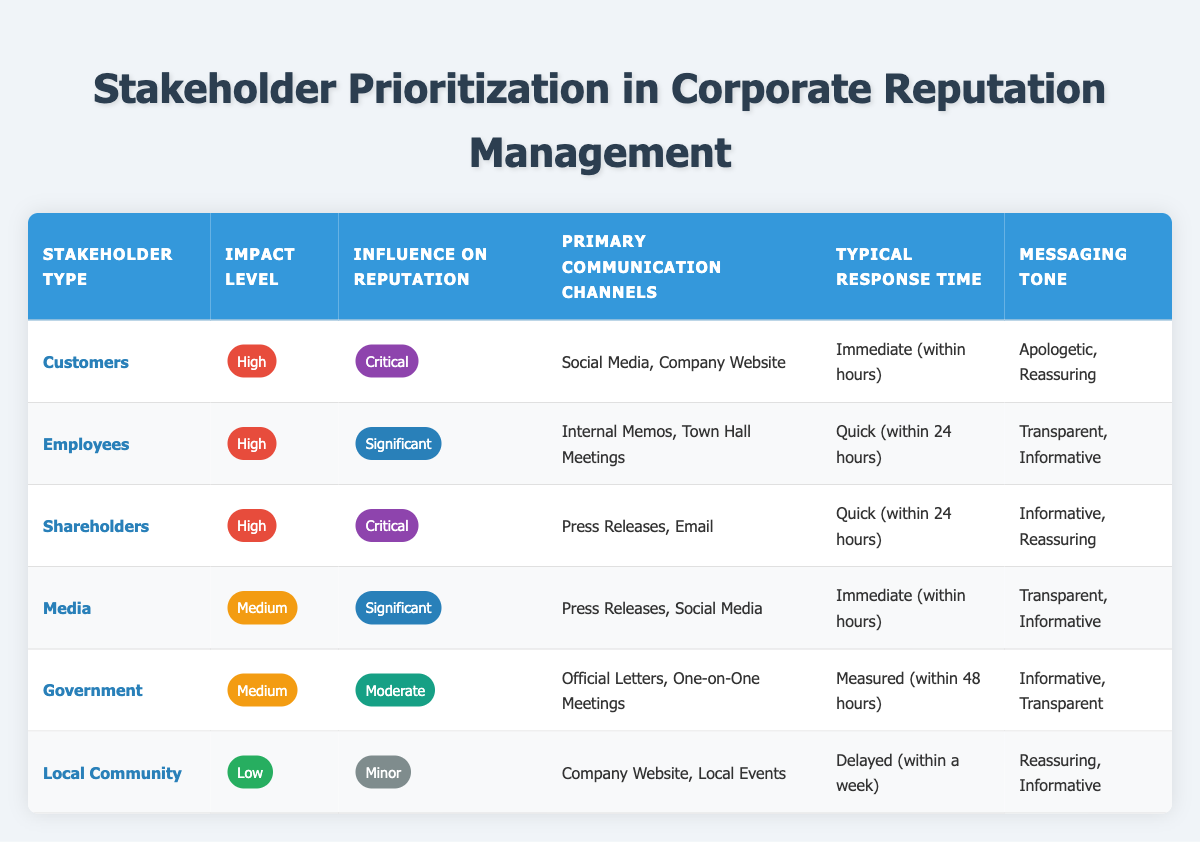What is the primary communication channel for employees? The table lists the primary communication channels for employees as "Internal Memos, Town Hall Meetings."
Answer: Internal Memos, Town Hall Meetings Which stakeholder type has a low impact level? In the table, local community is categorized under a low impact level.
Answer: Local Community How many stakeholder types have a critical influence on reputation? The table shows two stakeholder types: Customers and Shareholders which have a critical influence on reputation.
Answer: 2 What is the typical response time for shareholders? The table indicates that the typical response time for shareholders is "Quick (within 24 hours)."
Answer: Quick (within 24 hours) Which communication channel is used for immediate responses? The table details that "Social Media" and "Press Releases" are used for immediate response channels.
Answer: Social Media, Press Releases What is the average impact level of the stakeholders presented in the table? The stakeholders categorized as "High" (Customers, Employees, Shareholders), "Medium" (Media, Government), and "Low" (Local Community) show that the average impact is mostly high, depending on the frequency of high levels. To summarize with a straightforward method, the impact levels can be simplified as 3 High, 2 Medium, and 1 Low, giving more weight to high overall.
Answer: High Is the messaging tone for local community primarily reassuring? Based on the table, the messaging tone for local community includes "Reassuring" and "Informative," confirming that it is primarily reassuring.
Answer: Yes Which stakeholder type has the significant influence on reputation and medium impact level? The table identifies "Media" as the stakeholder with significant influence on reputation and a medium impact level.
Answer: Media What is the relationship between response time and the impact level for customers? The table shows customers have a high impact level and an immediate response time (within hours), suggesting that stakeholders with high impact levels are prioritized for quicker responses.
Answer: Immediate response for high impact customers 